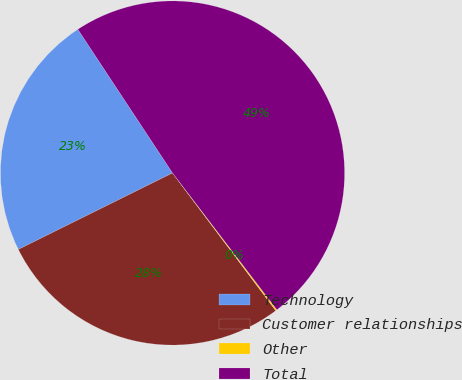Convert chart. <chart><loc_0><loc_0><loc_500><loc_500><pie_chart><fcel>Technology<fcel>Customer relationships<fcel>Other<fcel>Total<nl><fcel>23.05%<fcel>27.92%<fcel>0.13%<fcel>48.9%<nl></chart> 